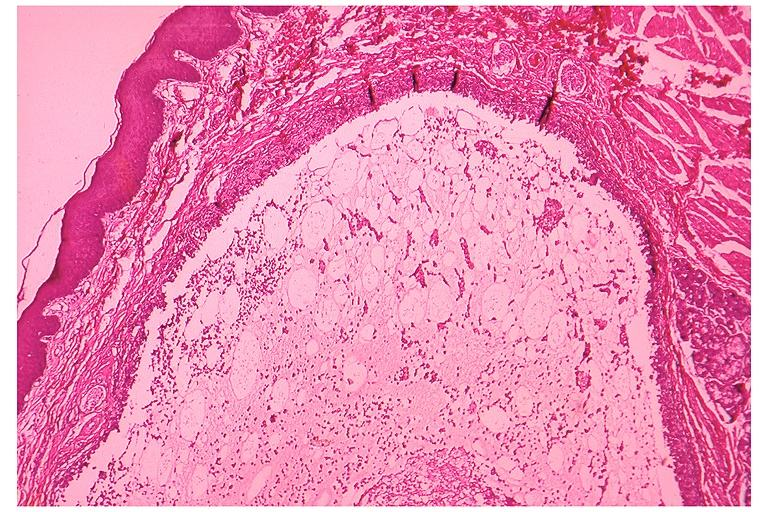s oral present?
Answer the question using a single word or phrase. Yes 